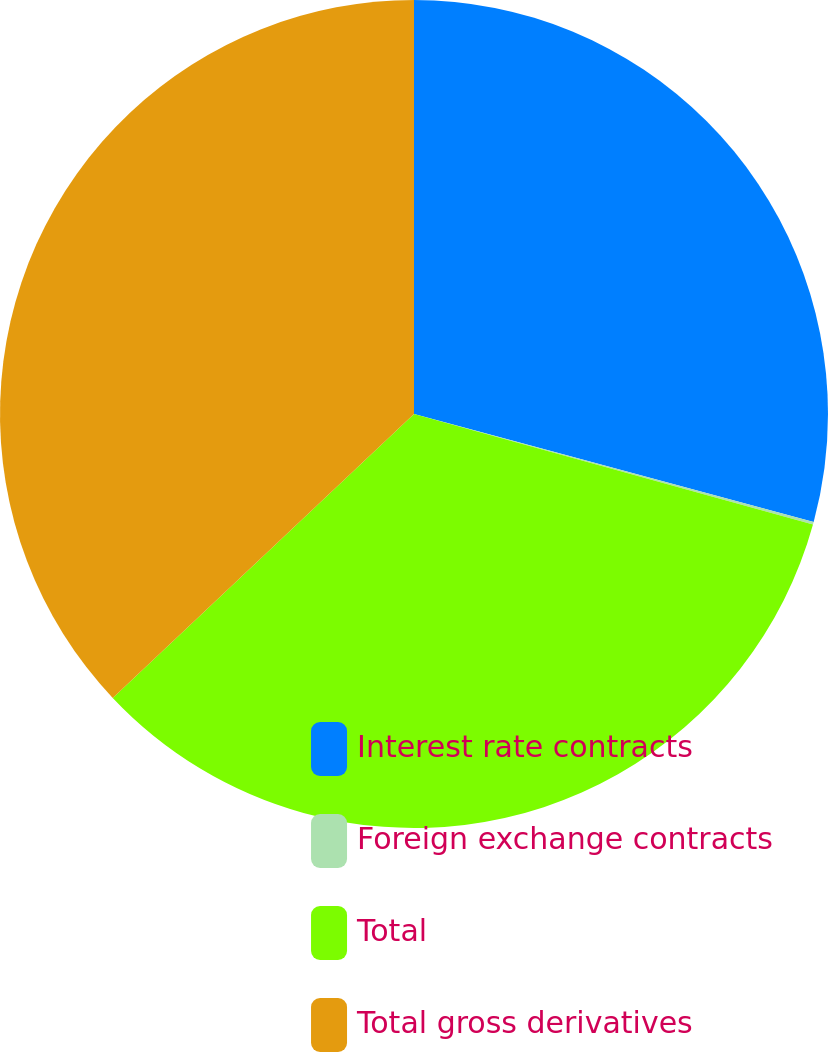Convert chart to OTSL. <chart><loc_0><loc_0><loc_500><loc_500><pie_chart><fcel>Interest rate contracts<fcel>Foreign exchange contracts<fcel>Total<fcel>Total gross derivatives<nl><fcel>29.2%<fcel>0.1%<fcel>33.67%<fcel>37.03%<nl></chart> 